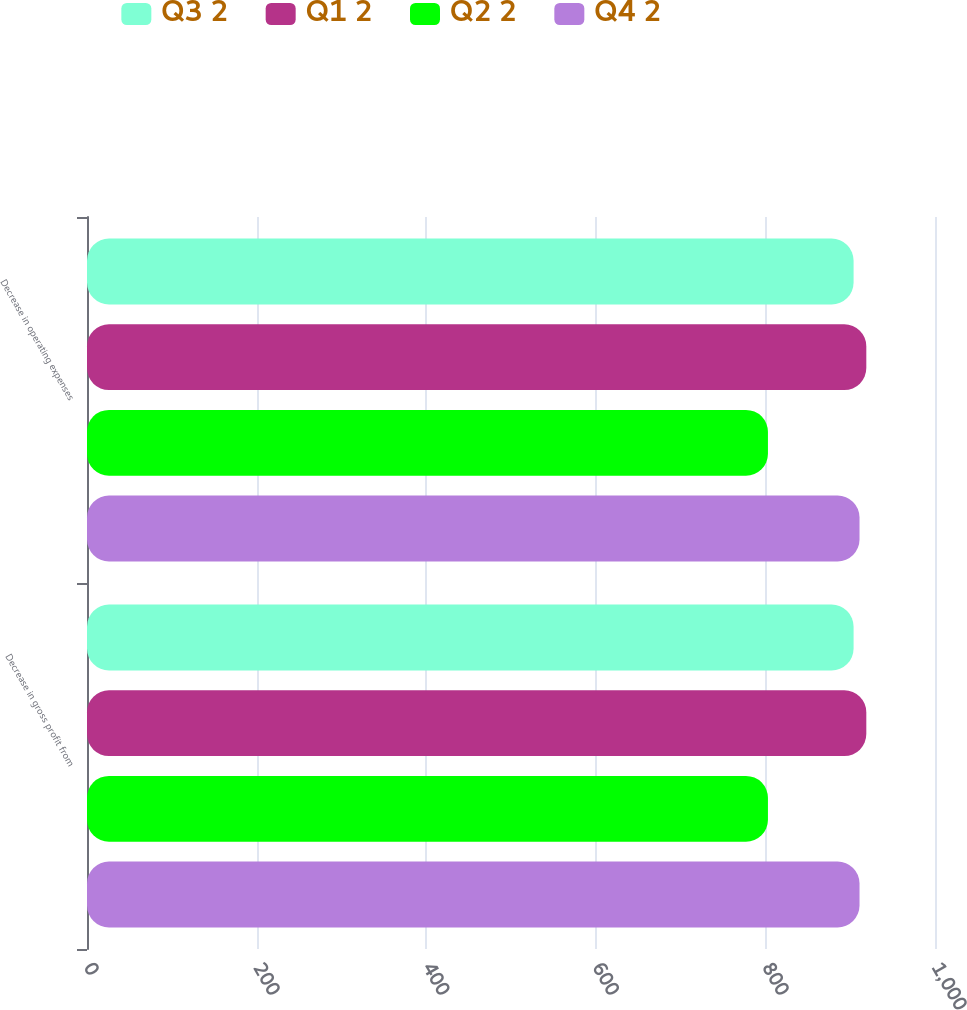<chart> <loc_0><loc_0><loc_500><loc_500><stacked_bar_chart><ecel><fcel>Decrease in gross profit from<fcel>Decrease in operating expenses<nl><fcel>Q3 2<fcel>904<fcel>904<nl><fcel>Q1 2<fcel>919<fcel>919<nl><fcel>Q2 2<fcel>803<fcel>803<nl><fcel>Q4 2<fcel>911<fcel>911<nl></chart> 